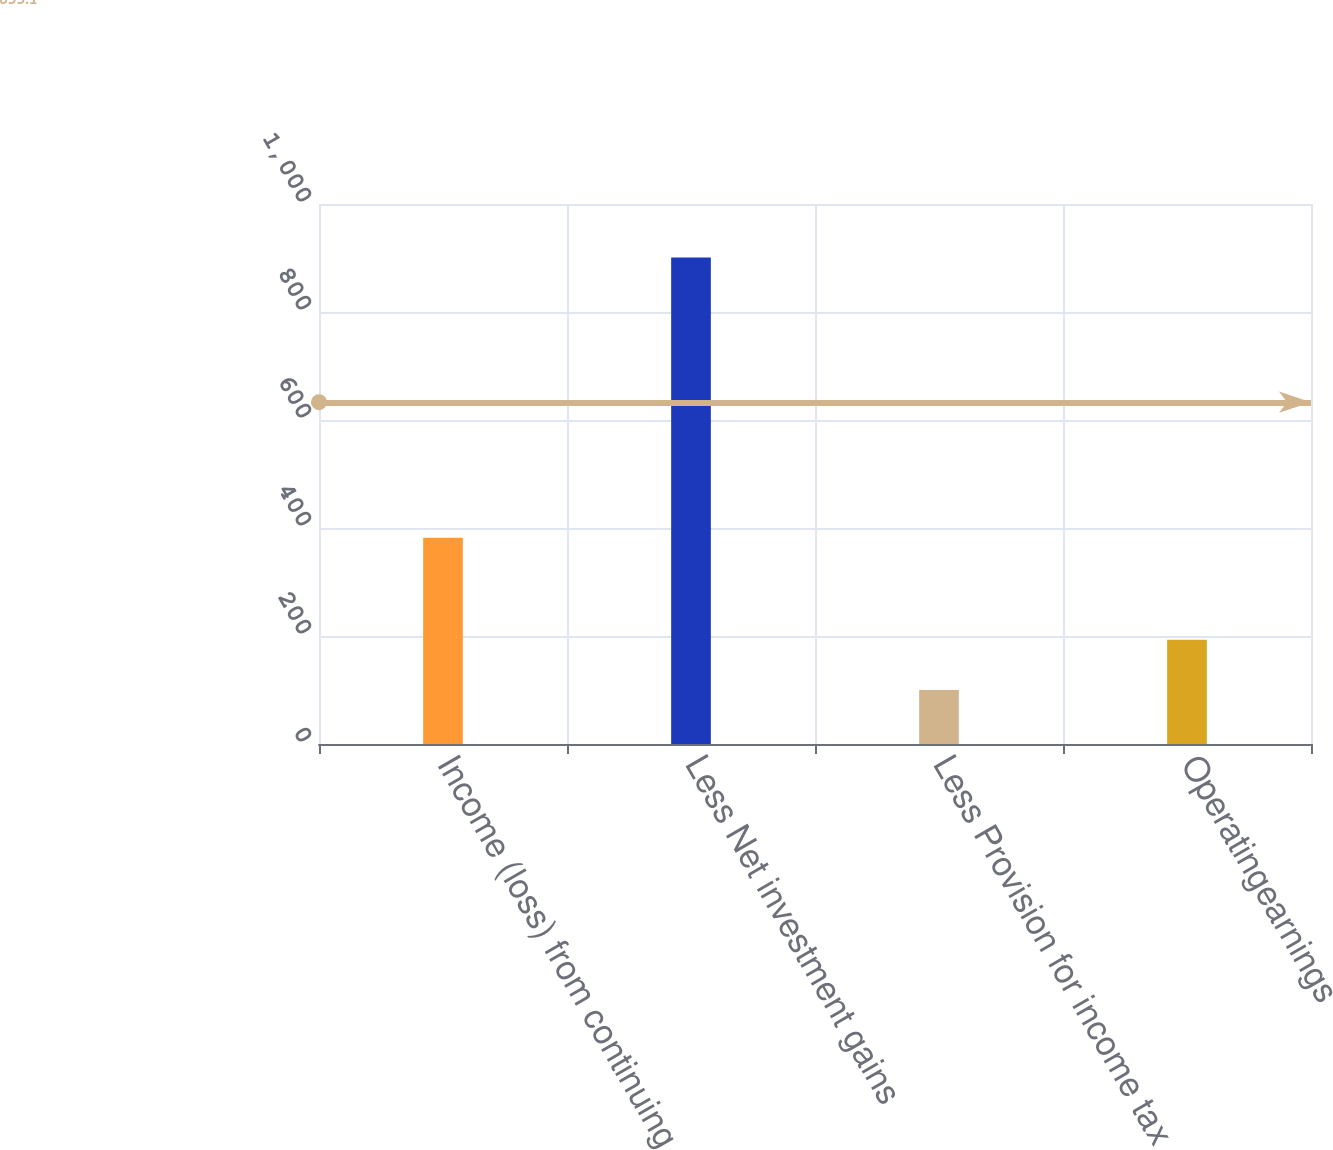<chart> <loc_0><loc_0><loc_500><loc_500><bar_chart><fcel>Income (loss) from continuing<fcel>Less Net investment gains<fcel>Less Provision for income tax<fcel>Operatingearnings<nl><fcel>382<fcel>901<fcel>100<fcel>193<nl></chart> 